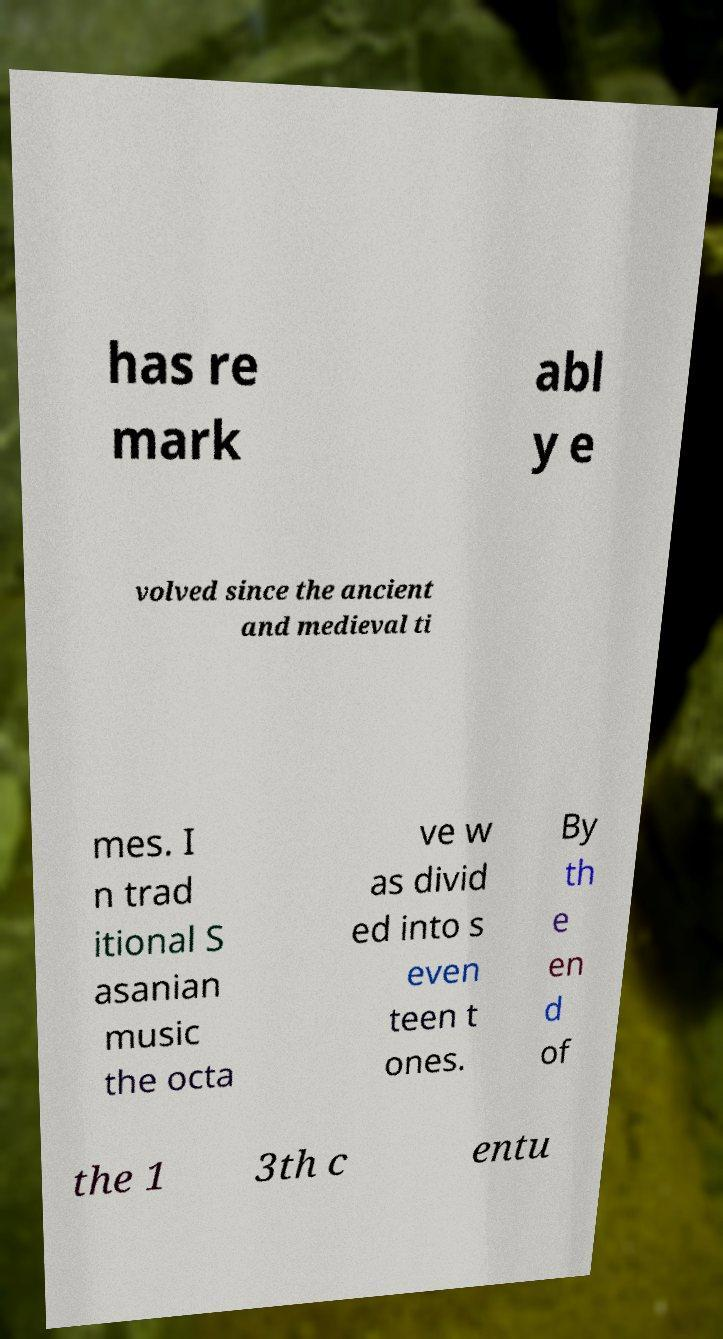What messages or text are displayed in this image? I need them in a readable, typed format. has re mark abl y e volved since the ancient and medieval ti mes. I n trad itional S asanian music the octa ve w as divid ed into s even teen t ones. By th e en d of the 1 3th c entu 